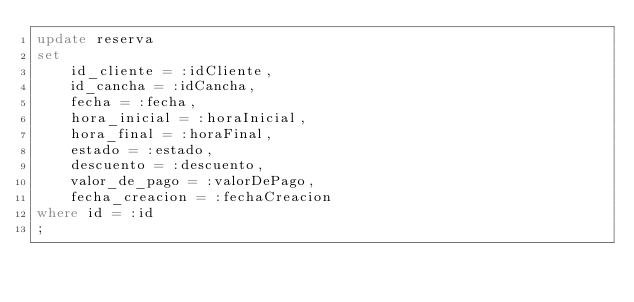<code> <loc_0><loc_0><loc_500><loc_500><_SQL_>update reserva
set
    id_cliente = :idCliente,
    id_cancha = :idCancha,
    fecha = :fecha,
    hora_inicial = :horaInicial,
    hora_final = :horaFinal,
    estado = :estado,
    descuento = :descuento,
    valor_de_pago = :valorDePago,
    fecha_creacion = :fechaCreacion
where id = :id
;</code> 